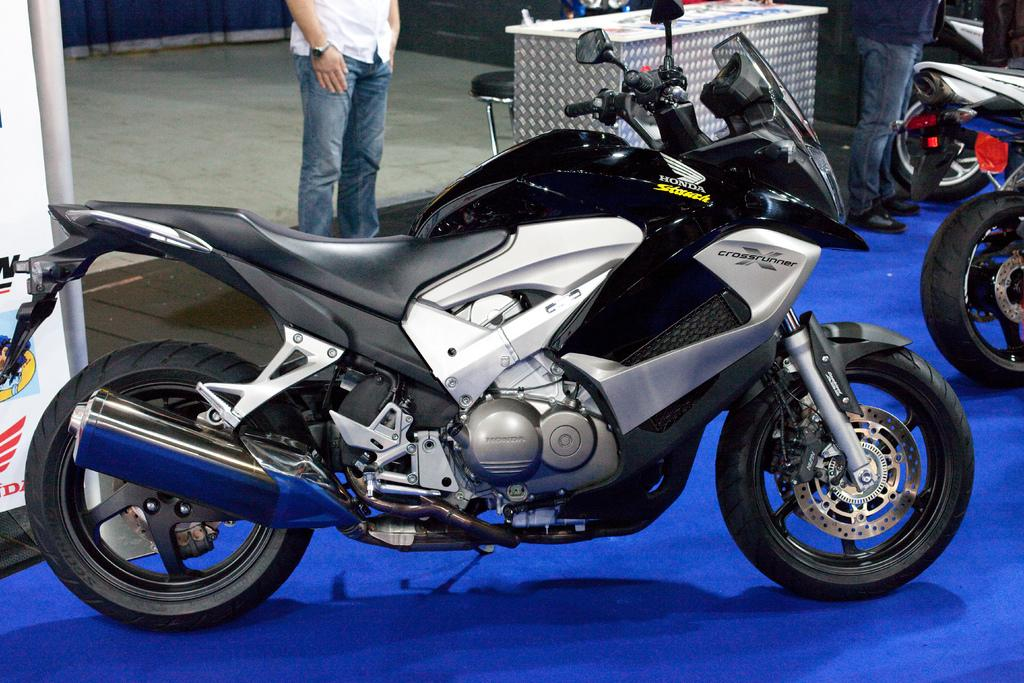What type of vehicles are on the blue surface in the image? There are bikes on a blue surface in the image. Can you describe the people in the image? There are people standing in the image. What is on the table in the image? There are objects on a table in the image. What is on the chair in the image? There are objects on a chair in the image. What is on the board in the image? There are objects on a board in the image. What is on the floor in the image? There are objects on the floor in the image. What type of head is visible on the bikes in the image? There are no heads visible on the bikes in the image; they are inanimate objects. Is there a camp set up in the image? There is no camp present in the image. What type of jelly can be seen on the blue surface? There is no jelly present in the image. 